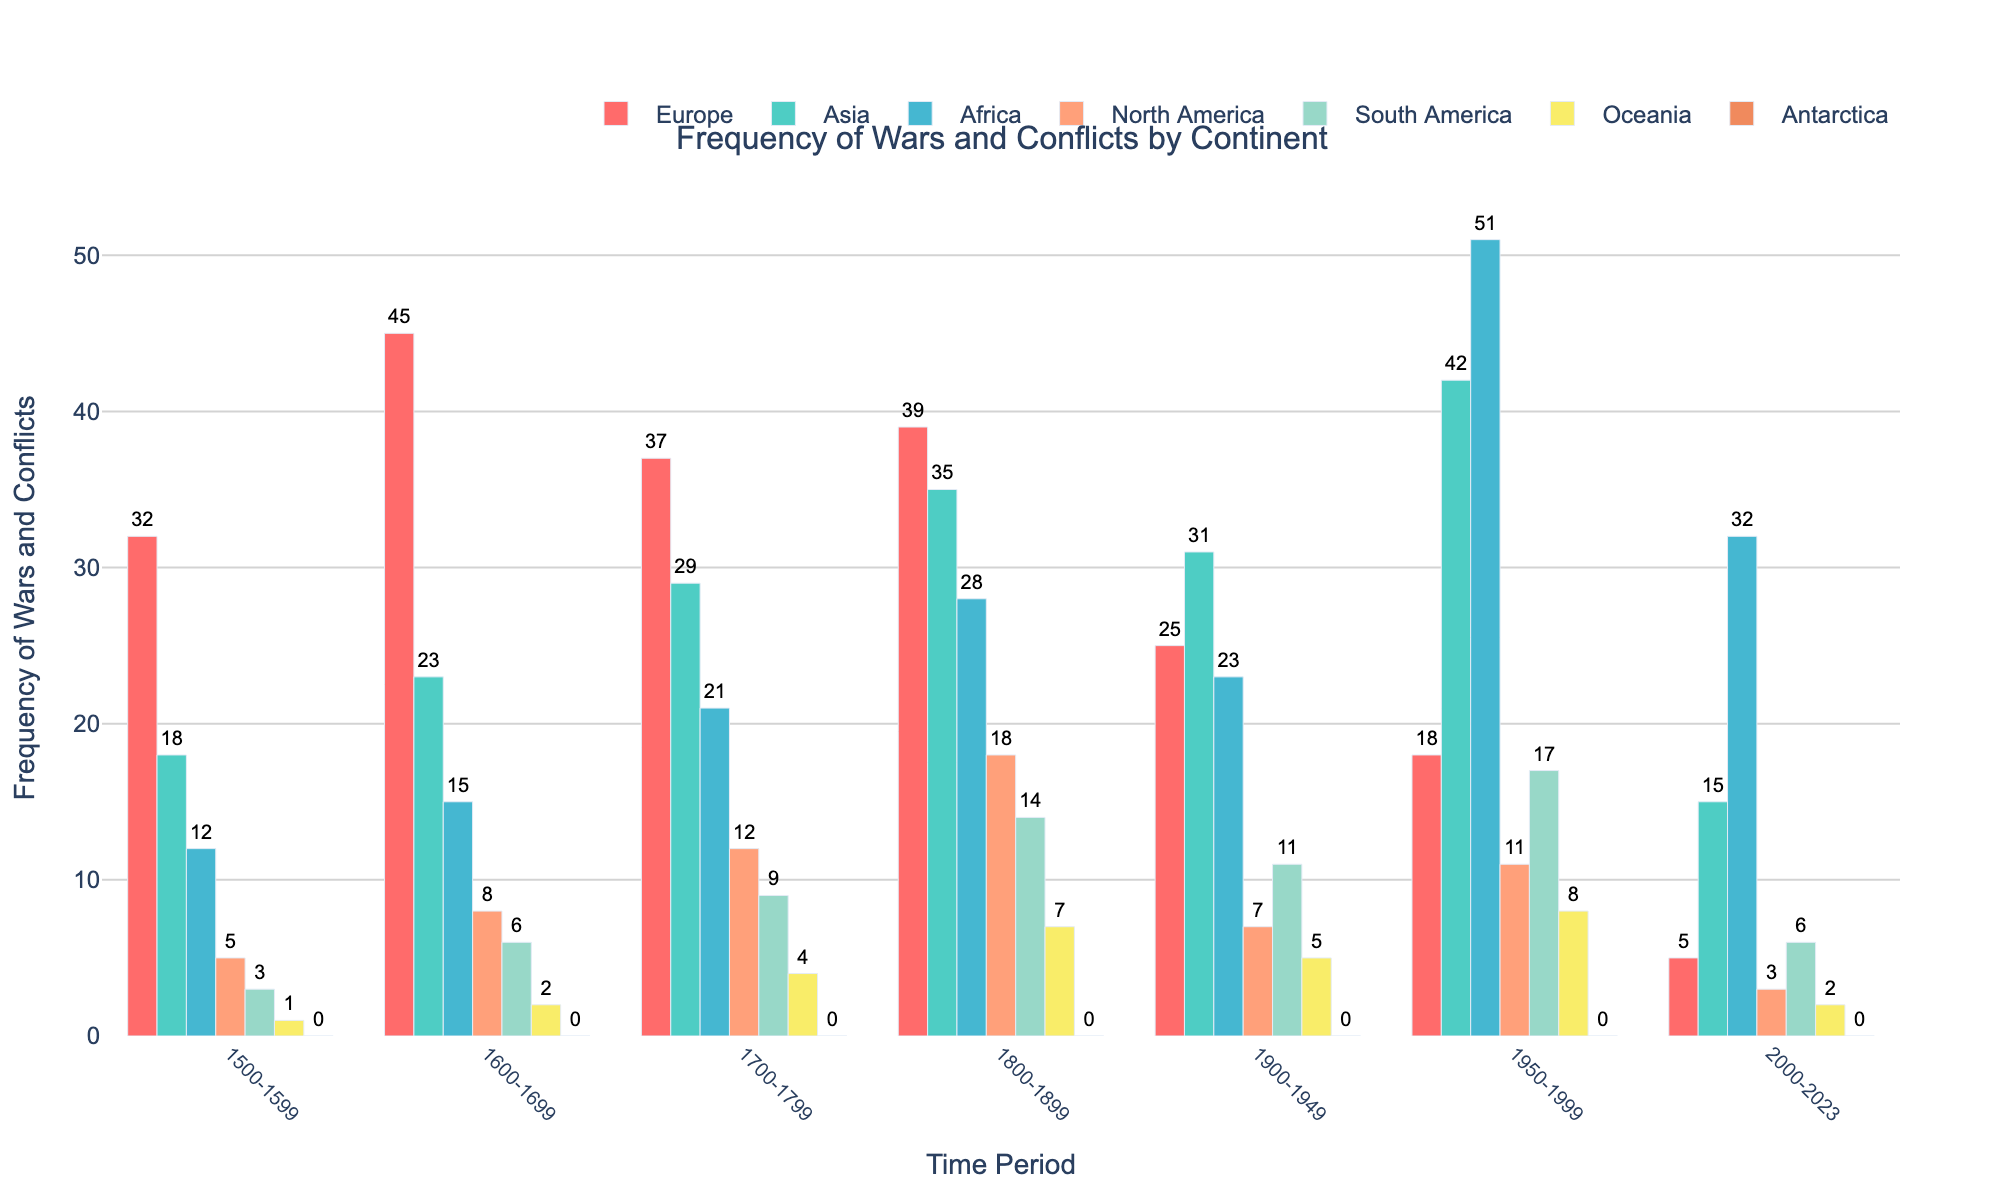What's the continent with the highest frequency of wars and conflicts from 1500-1599? Look at the bar heights in the 1500-1599 period. Europe has the highest bar, indicating the highest frequency.
Answer: Europe Which continent had the least frequency of wars and conflicts in the period 1800-1899? Observe the bar heights in the 1800-1899 period. Oceania has the shortest bar, indicating the least frequency.
Answer: Oceania By how much did the frequency of wars and conflicts in Africa increase from 1600-1699 to 2000-2023? Subtract the frequency in the 1600-1699 period (15) from the frequency in the 2000-2023 period (32). So the increase is 32 - 15 = 17.
Answer: 17 How many total wars and conflicts occurred in Asia from 1500-1999? Sum the frequencies from all periods for Asia: 18 + 23 + 29 + 35 + 31 + 42 = 178.
Answer: 178 Between Africa and South America, which had more wars and conflicts in 1900-1949? Compare the bar heights in the 1900-1949 period for Africa and South America. Africa's bar (23) is taller than South America's (11).
Answer: Africa What is the average frequency of wars and conflicts in Europe from 1500-1999? Add the frequencies for Europe from 1500-1999 and divide by the number of periods: (32 + 45 + 37 + 39 + 25 + 18) / 6 = 32.67.
Answer: 32.67 Which continent saw the most significant increase in the frequency of wars and conflicts from 1950-1999 compared to 1500-1599? Calculate the differences for each continent between the periods 1950-1999 and 1500-1599. Africa saw the highest increase: 51 - 12 = 39.
Answer: Africa During which period did North America have the highest frequency of wars and conflicts? Look for the tallest bar for North America. The tallest bar is in the 1800-1899 period (18).
Answer: 1800-1899 What is the combined frequency of wars and conflicts in Oceania and Antarctica in the 2000-2023 period? Add the frequencies of Oceania and Antarctica in 2000-2023: 2 + 0 = 2.
Answer: 2 Compare the frequency of wars and conflicts in Europe and Asia in the 1950-1999 period. Which one is higher and by how much? Compare the bar heights for Europe (18) and Asia (42) in the 1950-1999 period. Asia is higher by 42 - 18 = 24.
Answer: Asia by 24 